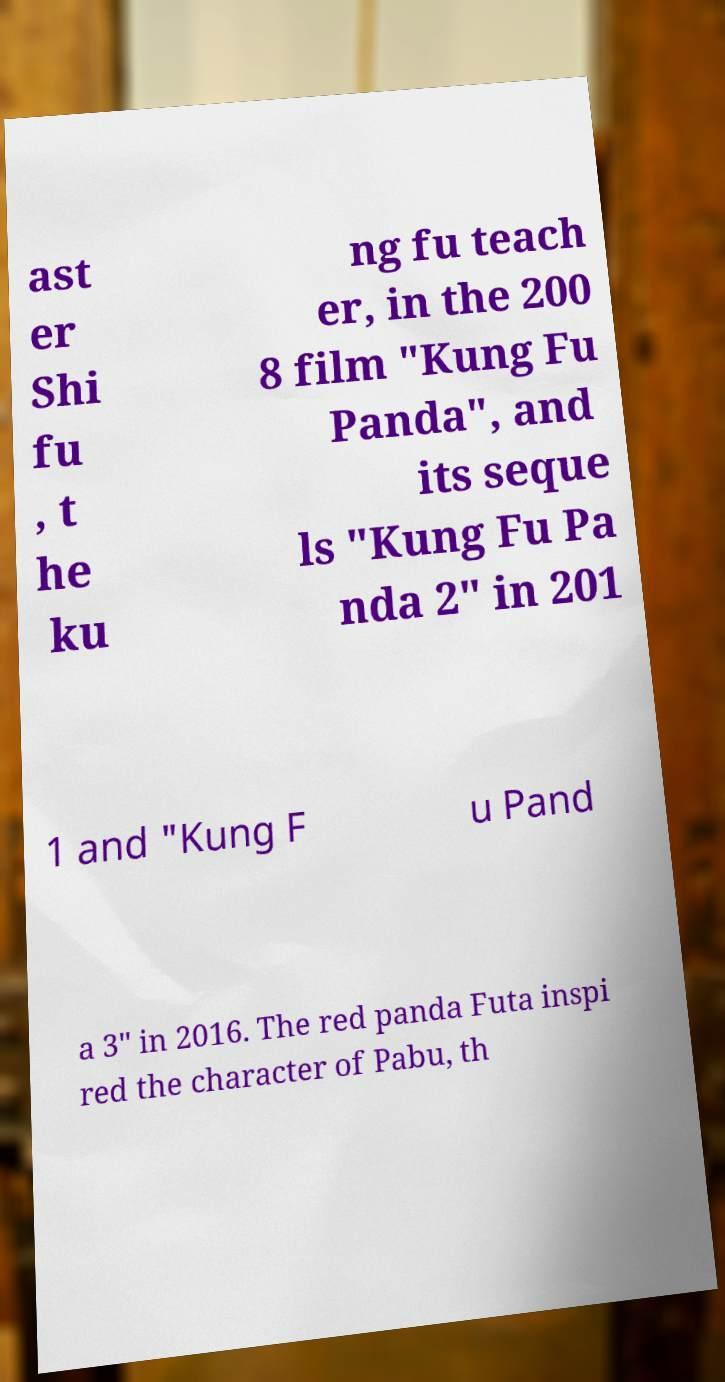For documentation purposes, I need the text within this image transcribed. Could you provide that? ast er Shi fu , t he ku ng fu teach er, in the 200 8 film "Kung Fu Panda", and its seque ls "Kung Fu Pa nda 2" in 201 1 and "Kung F u Pand a 3" in 2016. The red panda Futa inspi red the character of Pabu, th 